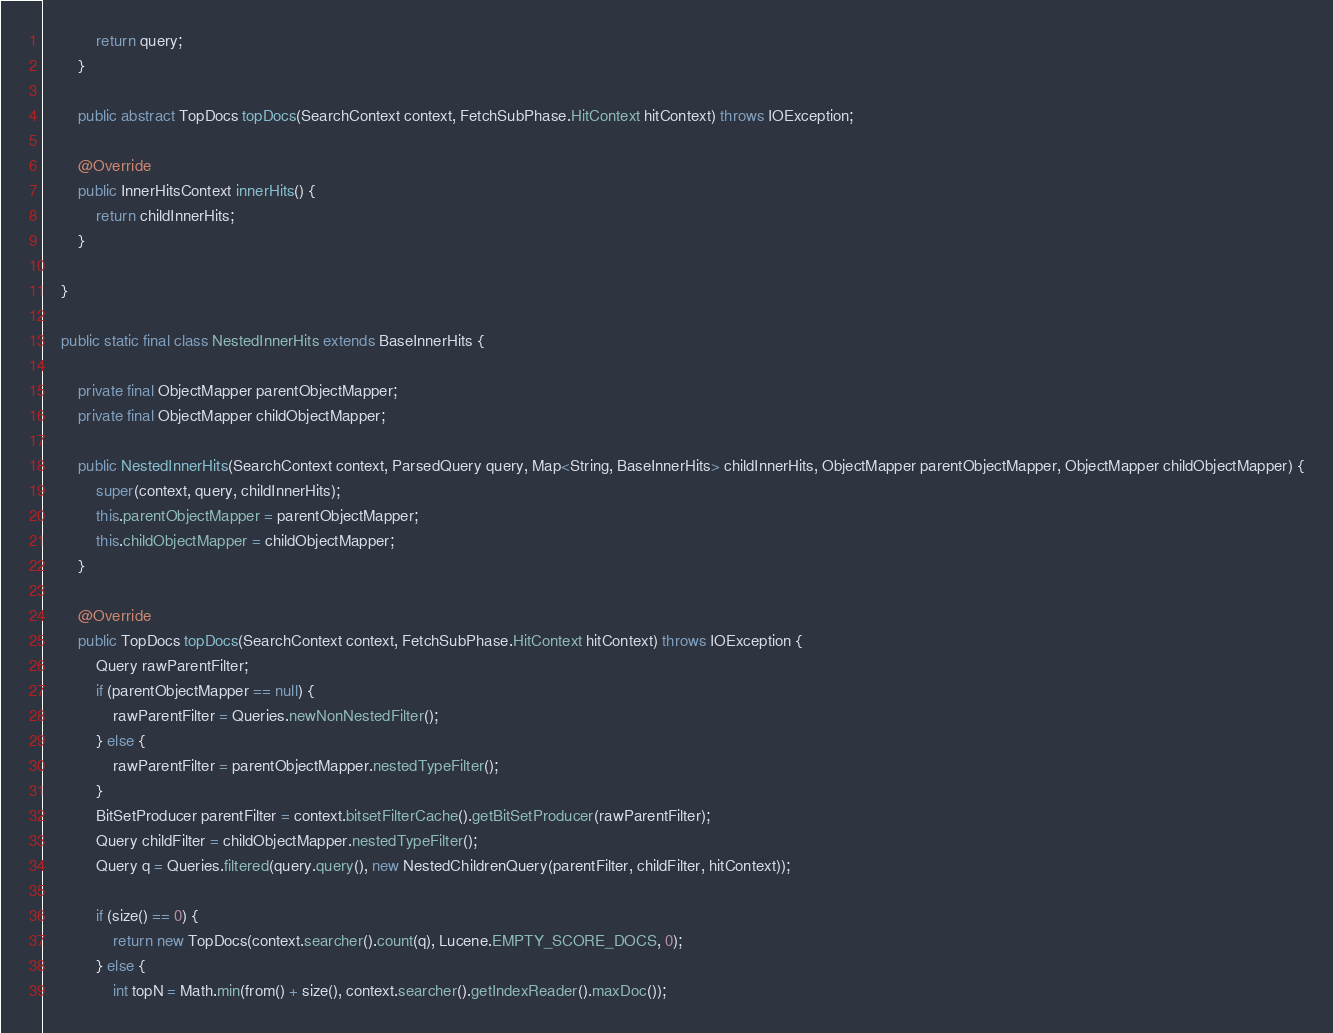<code> <loc_0><loc_0><loc_500><loc_500><_Java_>            return query;
        }

        public abstract TopDocs topDocs(SearchContext context, FetchSubPhase.HitContext hitContext) throws IOException;

        @Override
        public InnerHitsContext innerHits() {
            return childInnerHits;
        }

    }

    public static final class NestedInnerHits extends BaseInnerHits {

        private final ObjectMapper parentObjectMapper;
        private final ObjectMapper childObjectMapper;

        public NestedInnerHits(SearchContext context, ParsedQuery query, Map<String, BaseInnerHits> childInnerHits, ObjectMapper parentObjectMapper, ObjectMapper childObjectMapper) {
            super(context, query, childInnerHits);
            this.parentObjectMapper = parentObjectMapper;
            this.childObjectMapper = childObjectMapper;
        }

        @Override
        public TopDocs topDocs(SearchContext context, FetchSubPhase.HitContext hitContext) throws IOException {
            Query rawParentFilter;
            if (parentObjectMapper == null) {
                rawParentFilter = Queries.newNonNestedFilter();
            } else {
                rawParentFilter = parentObjectMapper.nestedTypeFilter();
            }
            BitSetProducer parentFilter = context.bitsetFilterCache().getBitSetProducer(rawParentFilter);
            Query childFilter = childObjectMapper.nestedTypeFilter();
            Query q = Queries.filtered(query.query(), new NestedChildrenQuery(parentFilter, childFilter, hitContext));

            if (size() == 0) {
                return new TopDocs(context.searcher().count(q), Lucene.EMPTY_SCORE_DOCS, 0);
            } else {
                int topN = Math.min(from() + size(), context.searcher().getIndexReader().maxDoc());</code> 